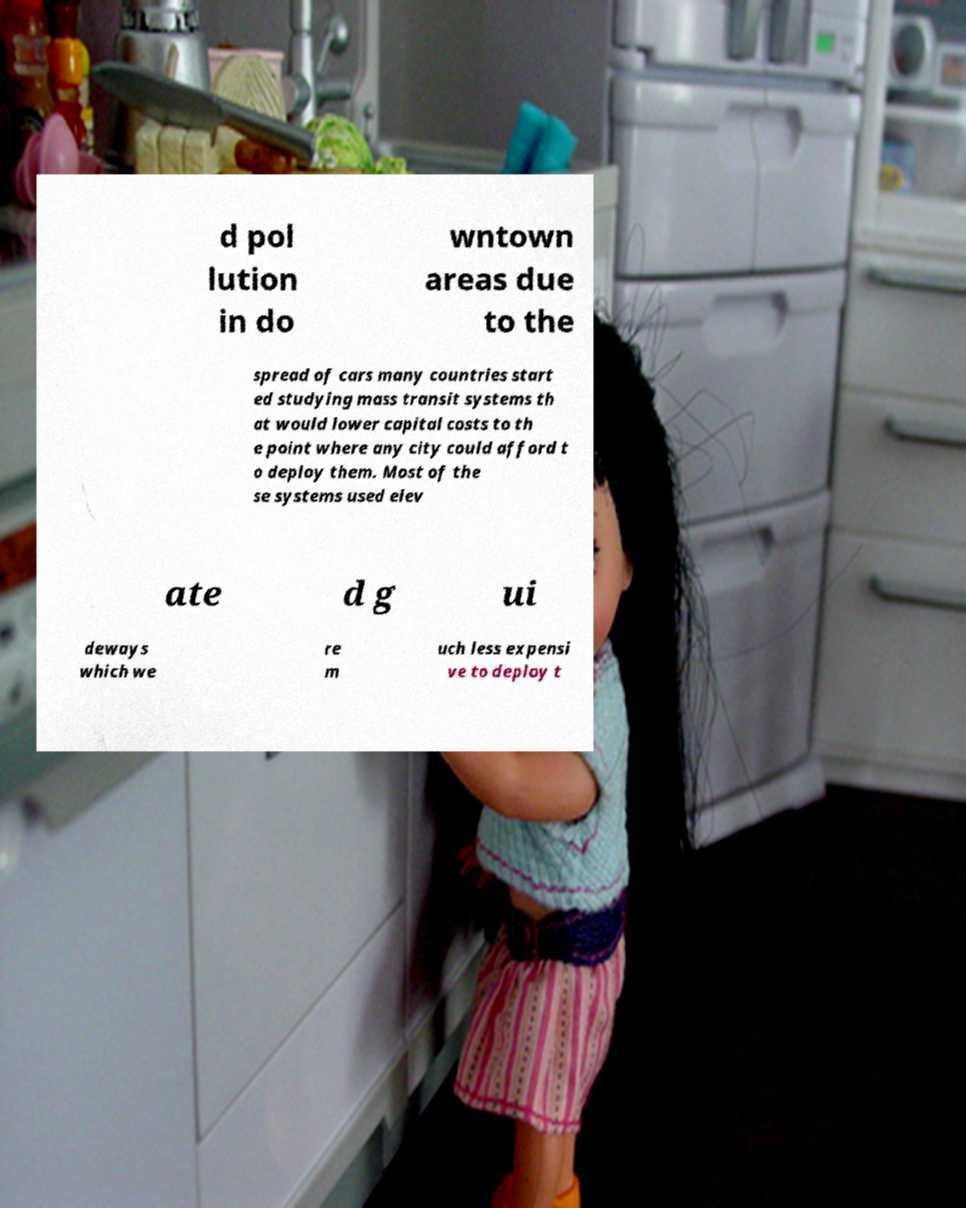Could you assist in decoding the text presented in this image and type it out clearly? d pol lution in do wntown areas due to the spread of cars many countries start ed studying mass transit systems th at would lower capital costs to th e point where any city could afford t o deploy them. Most of the se systems used elev ate d g ui deways which we re m uch less expensi ve to deploy t 